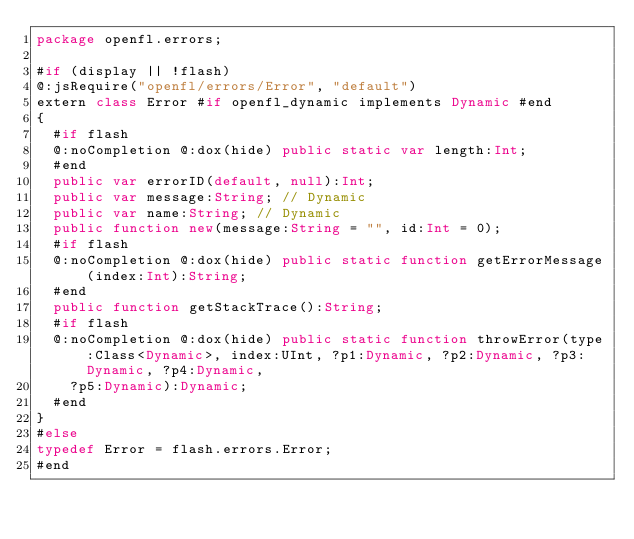Convert code to text. <code><loc_0><loc_0><loc_500><loc_500><_Haxe_>package openfl.errors;

#if (display || !flash)
@:jsRequire("openfl/errors/Error", "default")
extern class Error #if openfl_dynamic implements Dynamic #end
{
	#if flash
	@:noCompletion @:dox(hide) public static var length:Int;
	#end
	public var errorID(default, null):Int;
	public var message:String; // Dynamic
	public var name:String; // Dynamic
	public function new(message:String = "", id:Int = 0);
	#if flash
	@:noCompletion @:dox(hide) public static function getErrorMessage(index:Int):String;
	#end
	public function getStackTrace():String;
	#if flash
	@:noCompletion @:dox(hide) public static function throwError(type:Class<Dynamic>, index:UInt, ?p1:Dynamic, ?p2:Dynamic, ?p3:Dynamic, ?p4:Dynamic,
		?p5:Dynamic):Dynamic;
	#end
}
#else
typedef Error = flash.errors.Error;
#end
</code> 